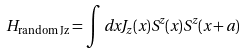<formula> <loc_0><loc_0><loc_500><loc_500>H _ { \text {random Jz} } = \int d x J _ { z } ( x ) S ^ { z } ( x ) S ^ { z } ( x + a )</formula> 